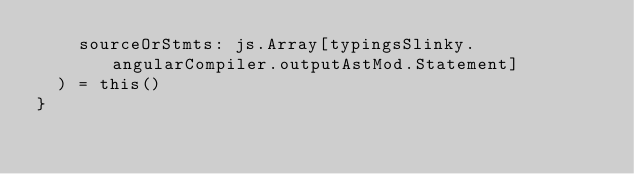<code> <loc_0><loc_0><loc_500><loc_500><_Scala_>    sourceOrStmts: js.Array[typingsSlinky.angularCompiler.outputAstMod.Statement]
  ) = this()
}
</code> 